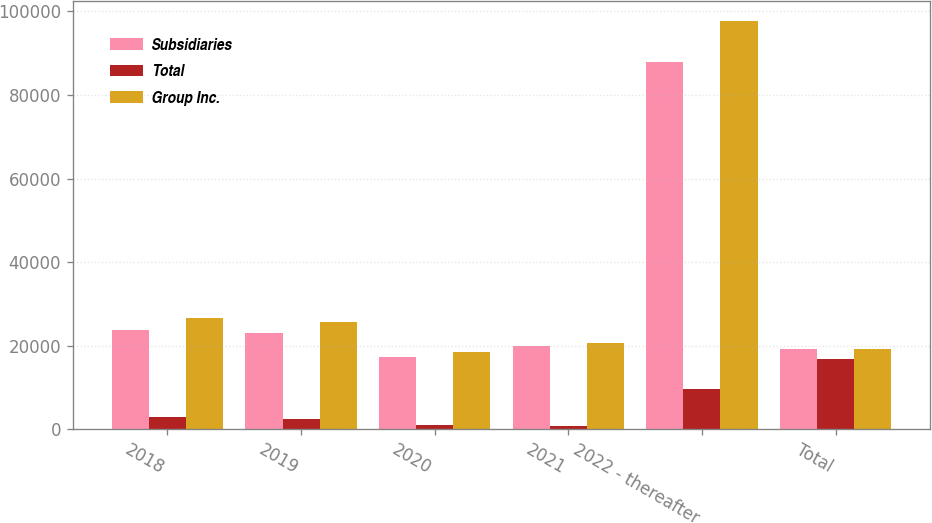Convert chart to OTSL. <chart><loc_0><loc_0><loc_500><loc_500><stacked_bar_chart><ecel><fcel>2018<fcel>2019<fcel>2020<fcel>2021<fcel>2022 - thereafter<fcel>Total<nl><fcel>Subsidiaries<fcel>23814<fcel>23012<fcel>17291<fcel>20005<fcel>88013<fcel>19207<nl><fcel>Total<fcel>2890<fcel>2582<fcel>1118<fcel>740<fcel>9621<fcel>16951<nl><fcel>Group Inc.<fcel>26704<fcel>25594<fcel>18409<fcel>20745<fcel>97634<fcel>19207<nl></chart> 